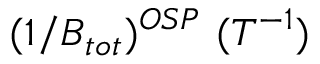<formula> <loc_0><loc_0><loc_500><loc_500>( 1 / B _ { t o t } ) ^ { O S P } ( T ^ { - 1 } )</formula> 